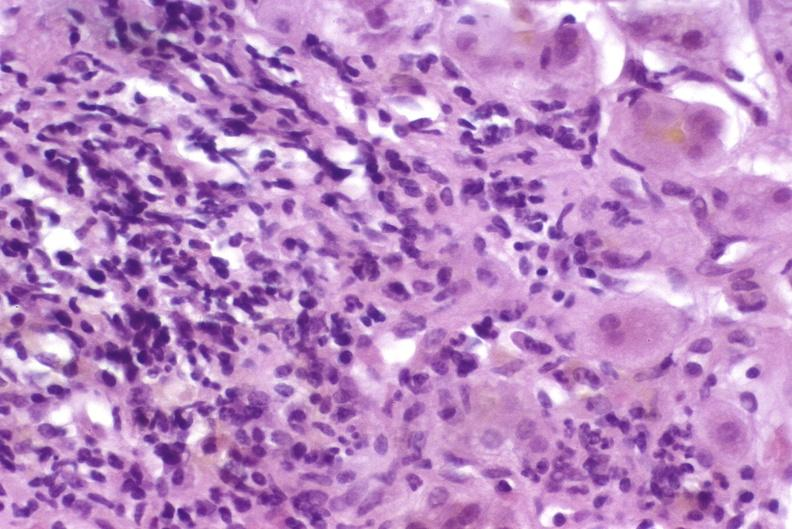s normal newborn present?
Answer the question using a single word or phrase. No 